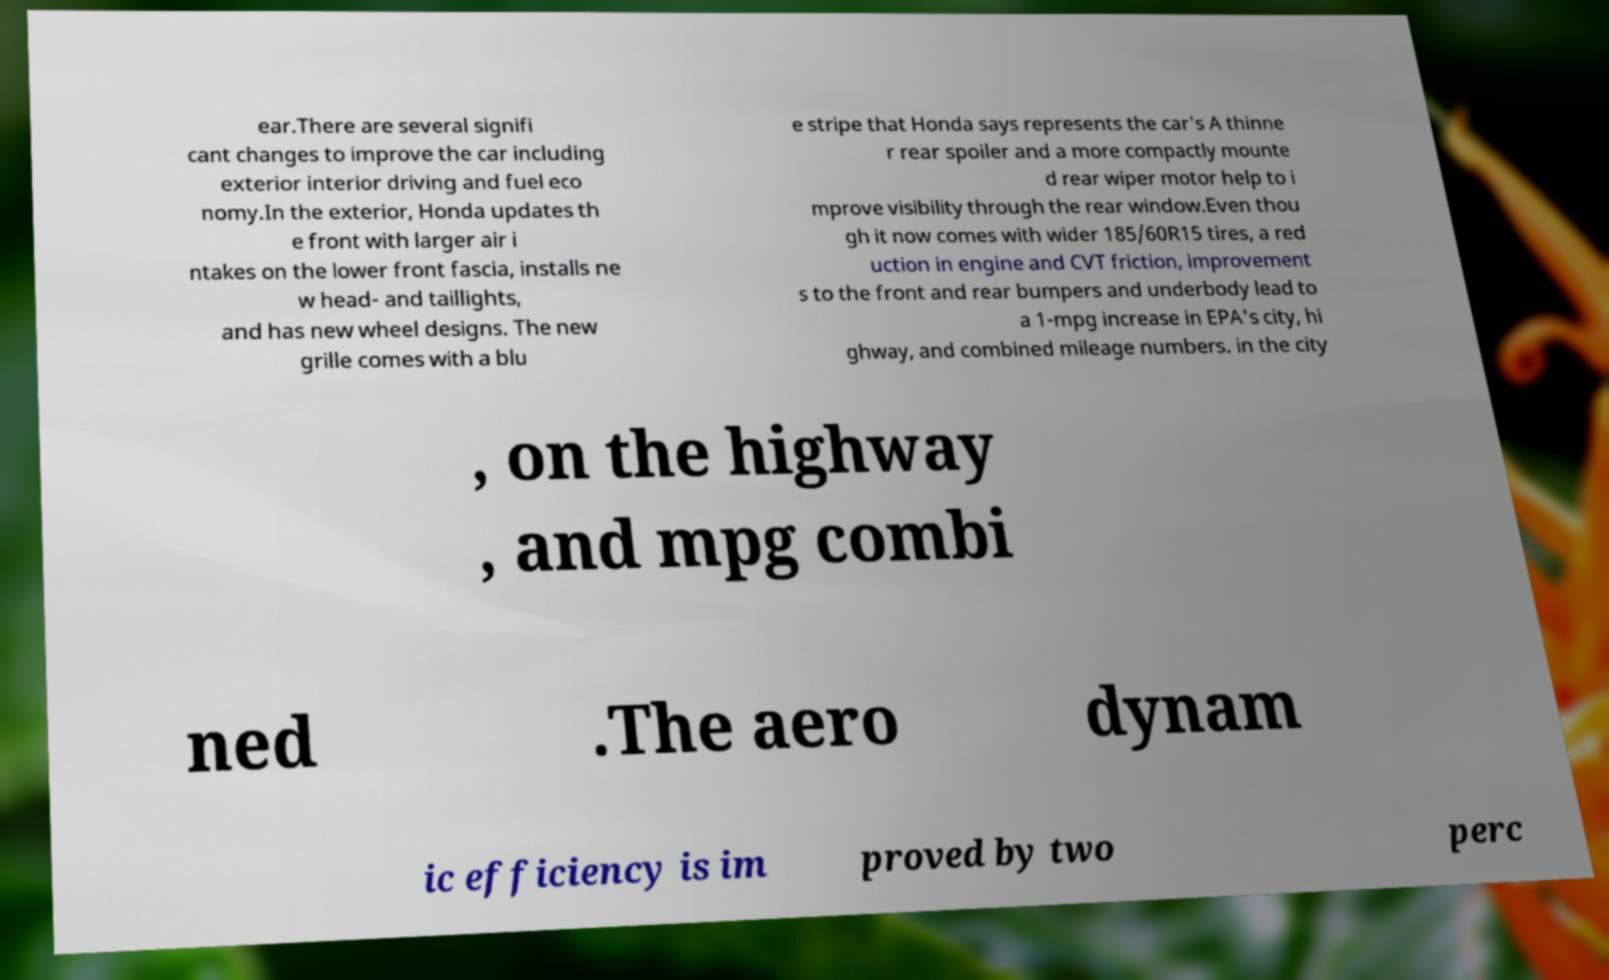What messages or text are displayed in this image? I need them in a readable, typed format. ear.There are several signifi cant changes to improve the car including exterior interior driving and fuel eco nomy.In the exterior, Honda updates th e front with larger air i ntakes on the lower front fascia, installs ne w head- and taillights, and has new wheel designs. The new grille comes with a blu e stripe that Honda says represents the car's A thinne r rear spoiler and a more compactly mounte d rear wiper motor help to i mprove visibility through the rear window.Even thou gh it now comes with wider 185/60R15 tires, a red uction in engine and CVT friction, improvement s to the front and rear bumpers and underbody lead to a 1-mpg increase in EPA's city, hi ghway, and combined mileage numbers. in the city , on the highway , and mpg combi ned .The aero dynam ic efficiency is im proved by two perc 